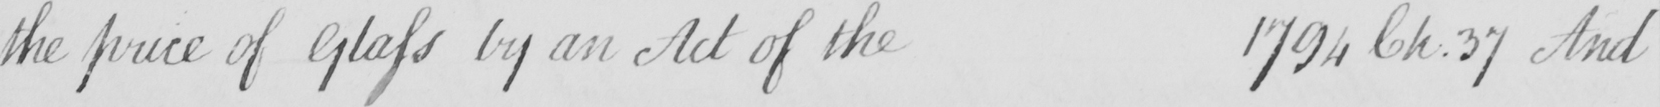Can you read and transcribe this handwriting? the price of Glass by an Act of the 1794 Ch.37 And 